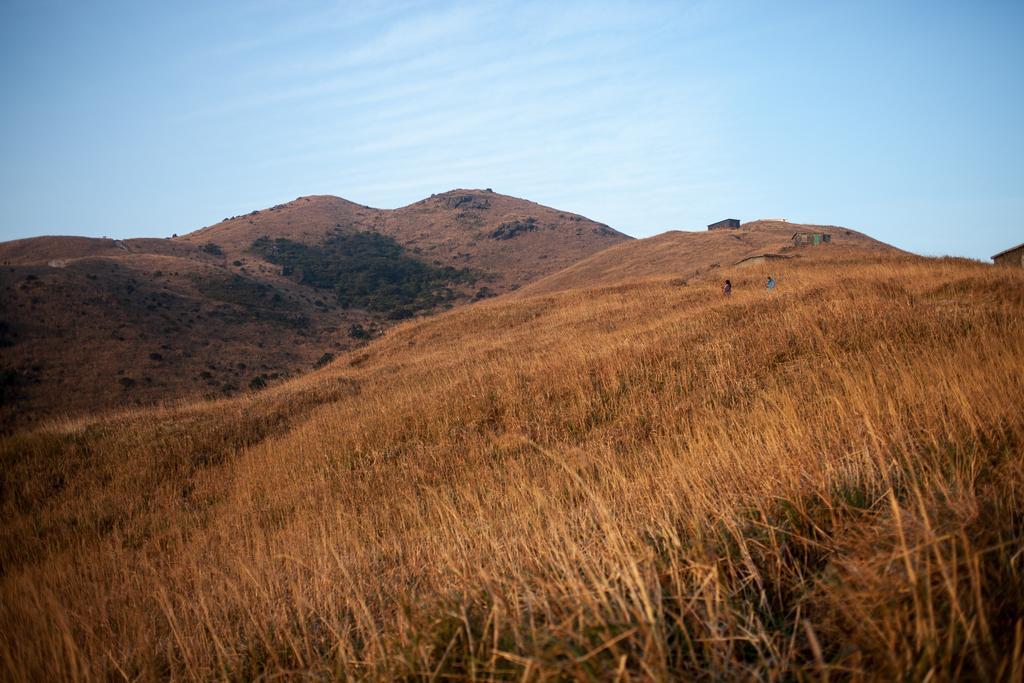Can you describe this image briefly? In this picture there are mountains and there are houses on the mountains and their might two people on the mountain. At the top there is sky and there are clouds. At the bottom there are plants and there is grass. 